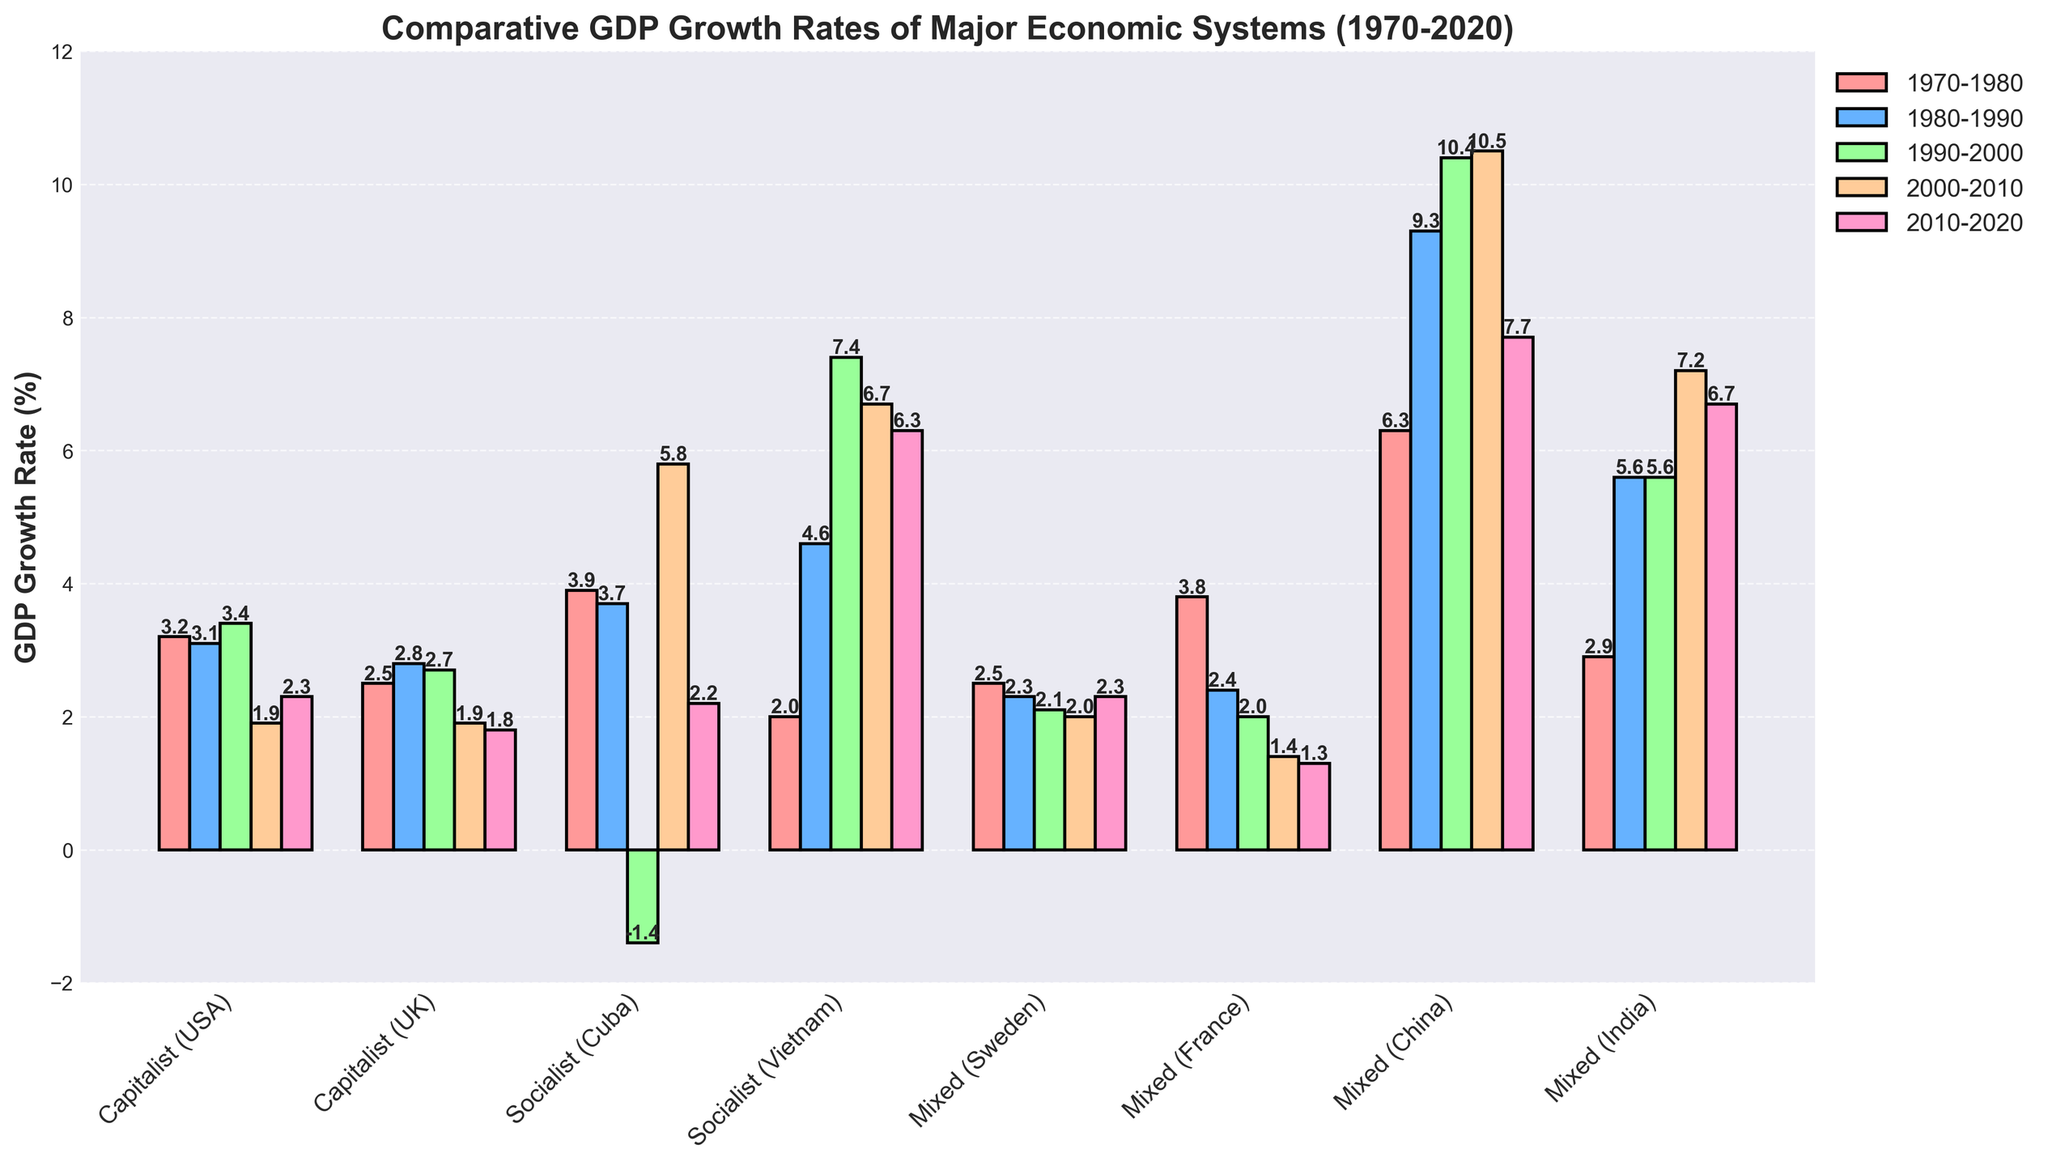Which economic system had the highest GDP growth rate in the 1970-1980 period? By observing the height of the bars in the 1970-1980 period, the tallest bar represents the Mixed (China) economic system.
Answer: Mixed (China) What was the average GDP growth rate of the Socialist economic systems (Cuba and Vietnam) during the 2010-2020 period? The GDP growth rates for Cuba and Vietnam in the 2010-2020 period are 2.2% and 6.3%, respectively. Adding these values: 2.2 + 6.3 = 8.5, and then dividing by 2 (number of countries), we get 8.5 / 2 = 4.25%.
Answer: 4.25% Which economic system showed a decline in GDP growth rate between the 1990-2000 and 2000-2010 periods? By comparing the bars for each economic system between 1990-2000 and 2000-2010, Socialist (Cuba) is the system that shows a decline from -1.4% to 5.8%.
Answer: Socialist (Cuba) How did the GDP growth rate for Capitalist (USA) change from the 2000-2010 period to the 2010-2020 period? The GDP growth rate for the USA was 1.9% during 2000-2010 and 2.3% during 2010-2020. The change is calculated as 2.3 - 1.9 = 0.4%.
Answer: 0.4% Which economic system had the most consistent GDP growth rate across all periods? By evaluating the visual consistency of the bar heights across all periods, Mixed (Sweden) appears to have the most consistent GDP growth rates, ranging roughly between 2.0% and 2.5%.
Answer: Mixed (Sweden) What was the difference in the GDP growth rate of Mixed (China) between the 1980-1990 and 1990-2000 periods? The GDP growth rate for China was 9.3% in the 1980-1990 period and 10.4% in the 1990-2000 period. The difference is 10.4 - 9.3 = 1.1%.
Answer: 1.1% Which economic system showed the highest GDP growth rate overall during the entire 50-year period? By examining the highest bar in the entire plot, the 10.5% growth rate for Mixed (China) in the 2000-2010 period is the highest.
Answer: Mixed (China) Which period saw the lowest GDP growth rate for Socialist (Cuba) and what was the value? Observing the shortest bar in Socialist (Cuba), the lowest GDP growth rate was -1.4% during the 1990-2000 period.
Answer: 1990-2000, -1.4% How did the GDP growth rates for Mixed (India) change from the 1970-1980 period to the 2010-2020 period? The GDP growth rate for India was 2.9% in 1970-1980 and 6.7% in the 2010-2020 period. The change can be calculated as 6.7 - 2.9 = 3.8%.
Answer: 3.8% Which economic system had a negative GDP growth rate in any of the periods shown, and during which period did this occur? By looking for any negative bars, Socialist (Cuba) had a negative growth rate of -1.4% during the 1990-2000 period.
Answer: Socialist (Cuba), 1990-2000 